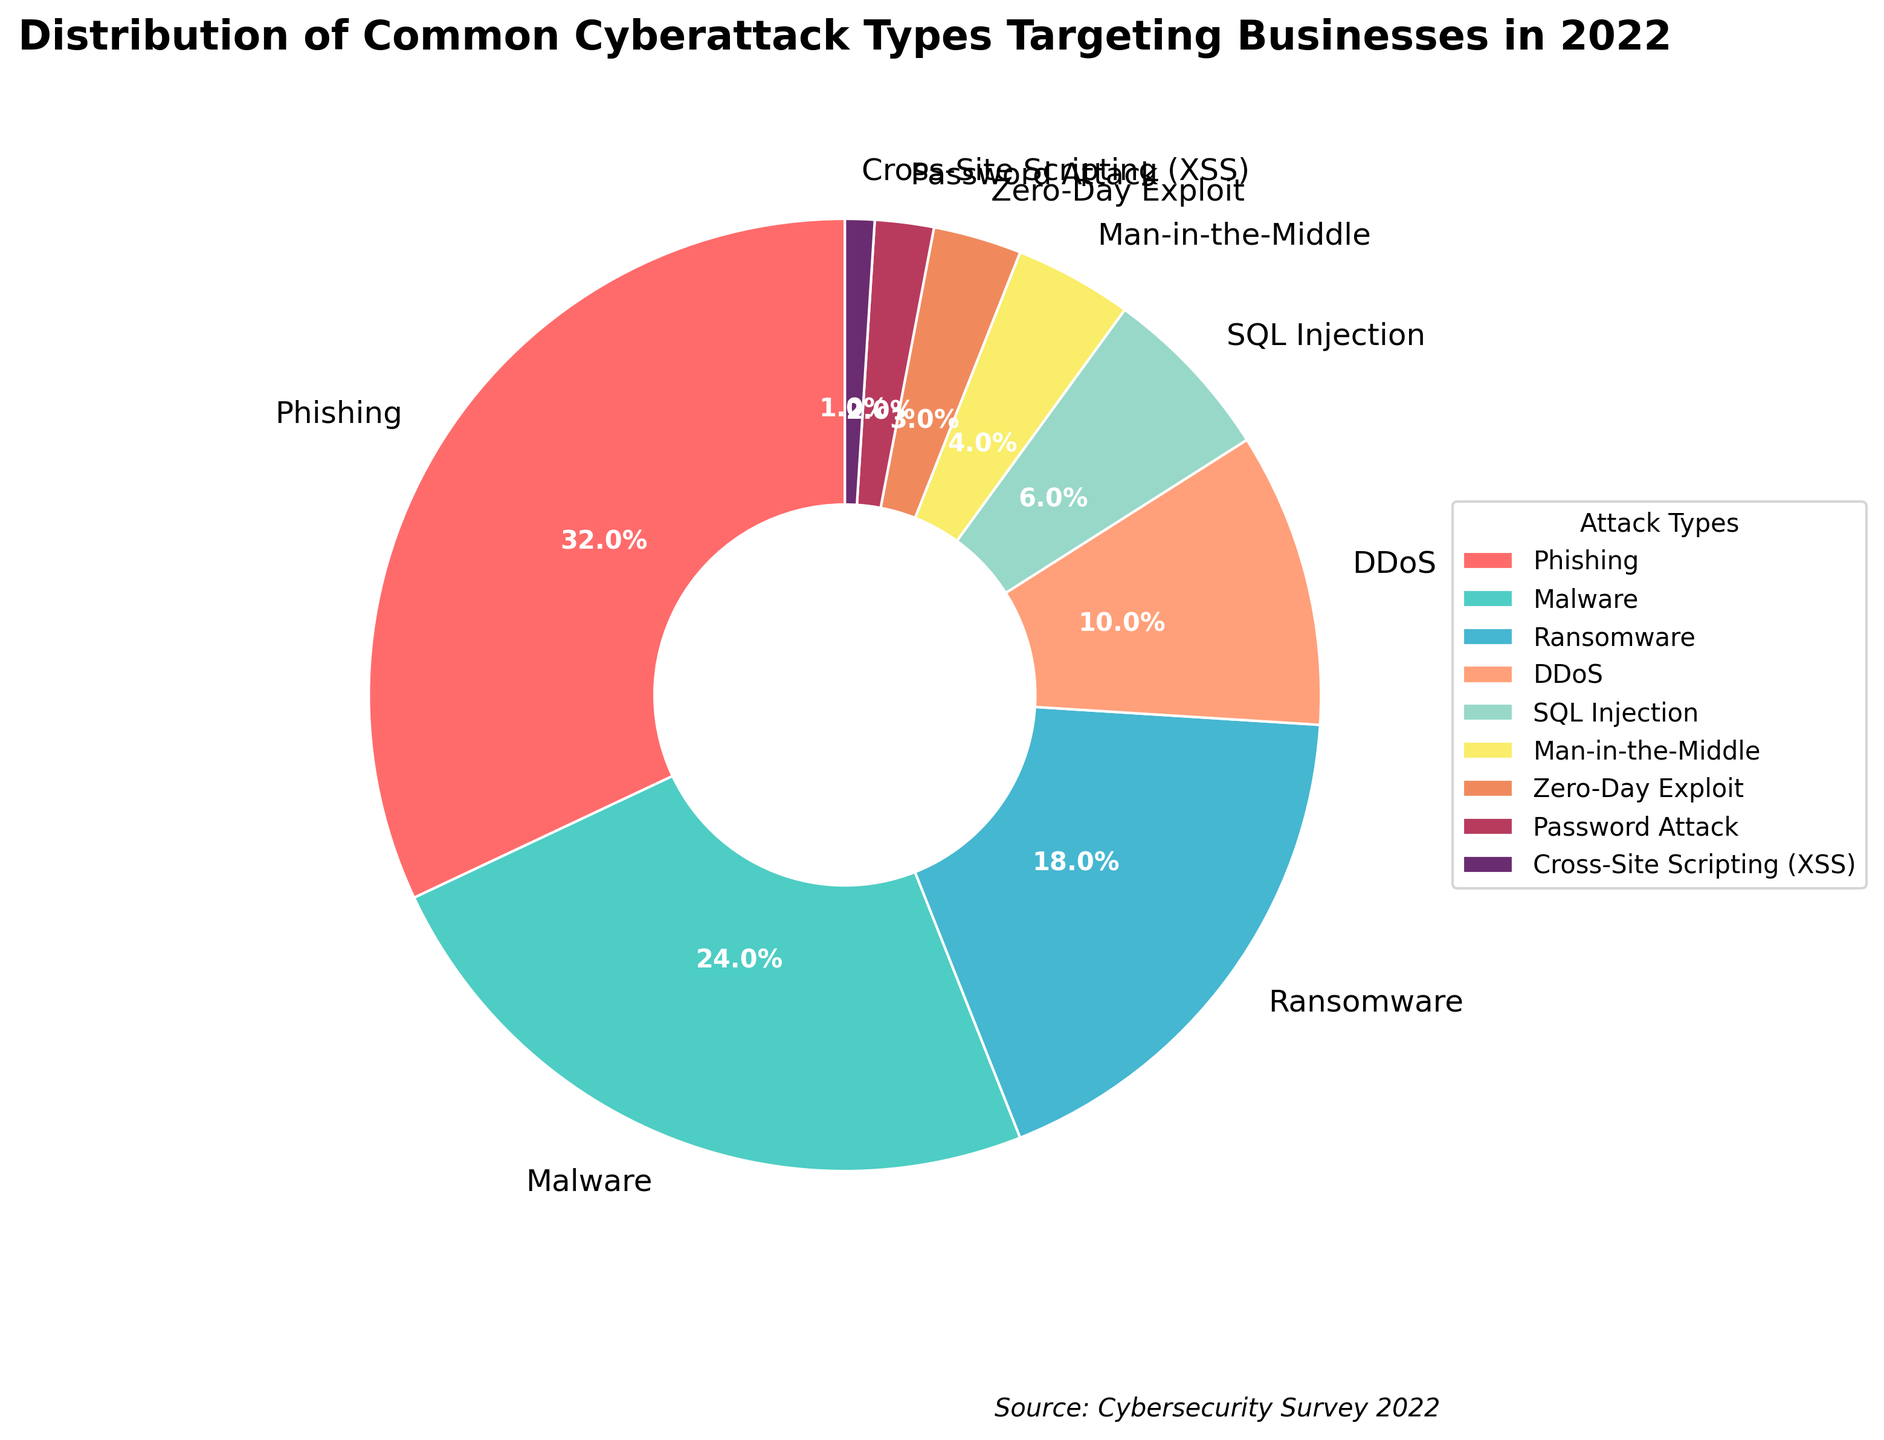Which type of cyberattack had the highest percentage? The highest percentage is represented by the largest slice of the pie chart. The slice for Phishing is the largest, indicating its percentage is higher than any other type shown.
Answer: Phishing What's the combined percentage of Phishing and Malware attacks? Look at the percentages for Phishing and Malware, which are 32% and 24% respectively. Adding these together gives 32 + 24 = 56%.
Answer: 56% Which cyberattack types had single-digit percentages? Identify the slices with percentages less than 10%. The types with single-digit percentages are SQL Injection (6%), Man-in-the-Middle (4%), Zero-Day Exploit (3%), Password Attack (2%), and Cross-Site Scripting (XSS) (1%).
Answer: SQL Injection, Man-in-the-Middle, Zero-Day Exploit, Password Attack, Cross-Site Scripting (XSS) Which attack type occupies the smallest slice? The smallest segment of the pie chart represents the lowest percentage. Cross-Site Scripting (XSS) is the smallest slice at 1%.
Answer: Cross-Site Scripting (XSS) How much larger in percentage is Phishing compared to Ransomware? Subtract the percentage of Ransomware (18%) from the percentage of Phishing (32%). The difference is 32 - 18 = 14%.
Answer: 14% What is the second most common cyberattack type after Phishing? The second largest slice, after Phishing, is for Malware, which has the second highest percentage at 24%.
Answer: Malware What is the total percentage of all attack types combined, excluding the top three types (Phishing, Malware, Ransomware)? First, add the percentages of the top three types: 32% (Phishing) + 24% (Malware) + 18% (Ransomware) = 74%. Subtract this from the total percentage (100%) to get the remaining percentage: 100 - 74 = 26%.
Answer: 26% Which attack type commonly associated with network threats is represented, and what's its percentage? The Distributed Denial of Service (DDoS) attack is commonly associated with network threats and has a slice representing 10%.
Answer: DDoS, 10% Between Password Attack and Man-in-the-Middle attacks, which one is more common, and by what percentage? Compare the slices for Password Attack (2%) and Man-in-the-Middle attacks (4%). Man-in-the-Middle is more common. To find the difference: 4 - 2 = 2%.
Answer: Man-in-the-Middle, 2% How does the percentage of Zero-Day Exploit compare to the combined percentage of Password Attack and Cross-Site Scripting (XSS)? The percentage for Zero-Day Exploit is 3%. Combine the percentages for Password Attack (2%) and Cross-Site Scripting (XSS) (1%): 2 + 1 = 3%. Both Zero-Day Exploit and the combined percentage of Password Attack and XSS are equal.
Answer: equal 